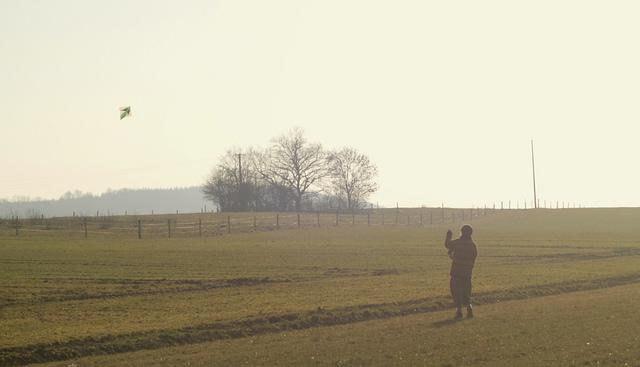What is in the picture?
Concise answer only. Kite. Is there a kite in the picture?
Keep it brief. Yes. Is this a farm?
Be succinct. Yes. What gender is the person in the photo?
Short answer required. Male. Is it sunny?
Short answer required. Yes. Is the person standing on grass?
Keep it brief. Yes. 